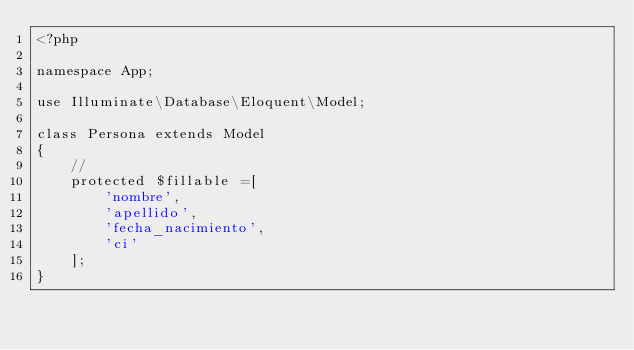<code> <loc_0><loc_0><loc_500><loc_500><_PHP_><?php

namespace App;

use Illuminate\Database\Eloquent\Model;

class Persona extends Model
{
    //
    protected $fillable =[
    	'nombre',
        'apellido',
        'fecha_nacimiento',
    	'ci'
    ];
}
</code> 